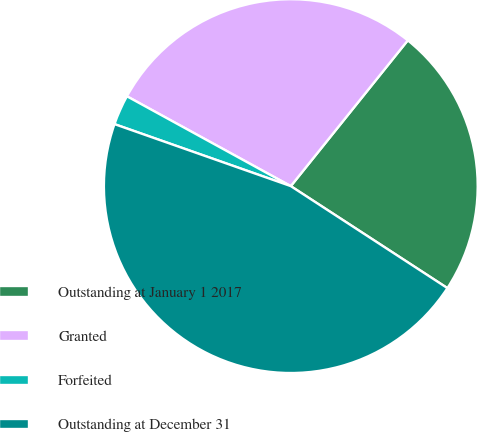<chart> <loc_0><loc_0><loc_500><loc_500><pie_chart><fcel>Outstanding at January 1 2017<fcel>Granted<fcel>Forfeited<fcel>Outstanding at December 31<nl><fcel>23.42%<fcel>27.78%<fcel>2.6%<fcel>46.19%<nl></chart> 